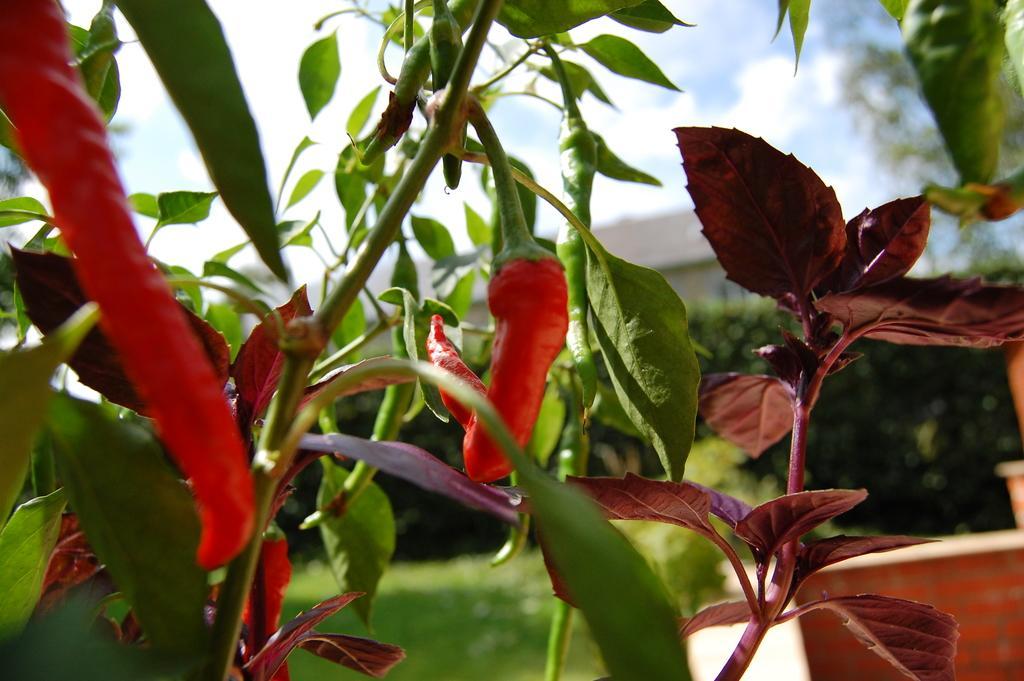Please provide a concise description of this image. In this image, I can see the red chilies to a plant. In the background, I can see hedges. Behind the hedges, It looks like a building. At the top of the image, there is the sky. 